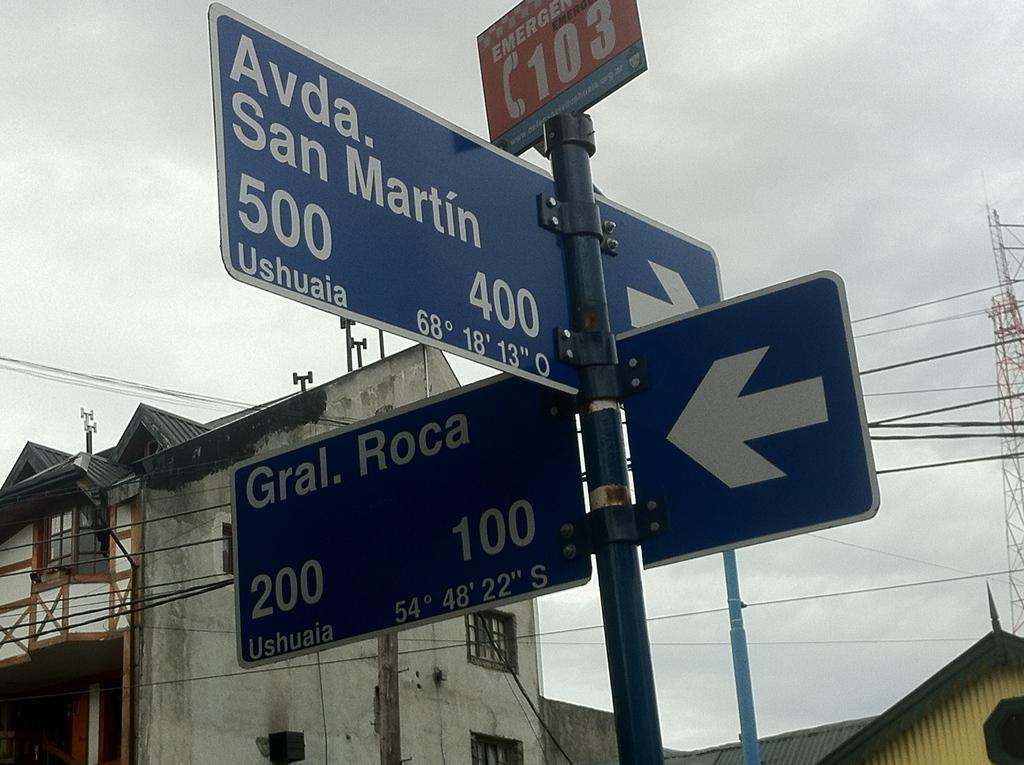Please provide a concise description of this image. In the image there is a pole and there are two direction boards and a caution board attached to that pole, behind that there is a building and there are plenty of wires in front of that building, on the right side there is a tower in the background. 